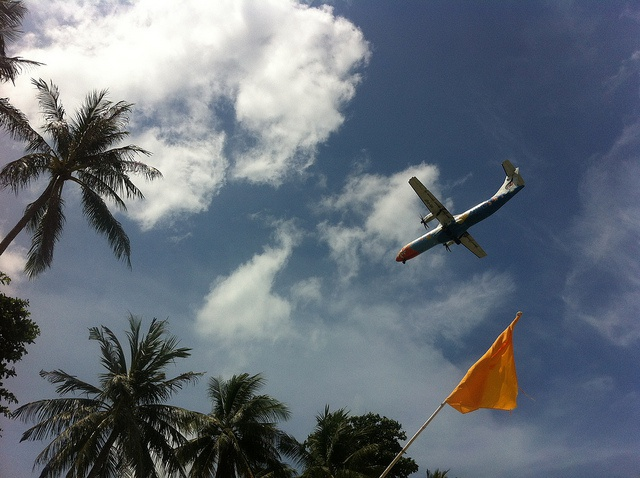Describe the objects in this image and their specific colors. I can see a airplane in black, gray, blue, and ivory tones in this image. 